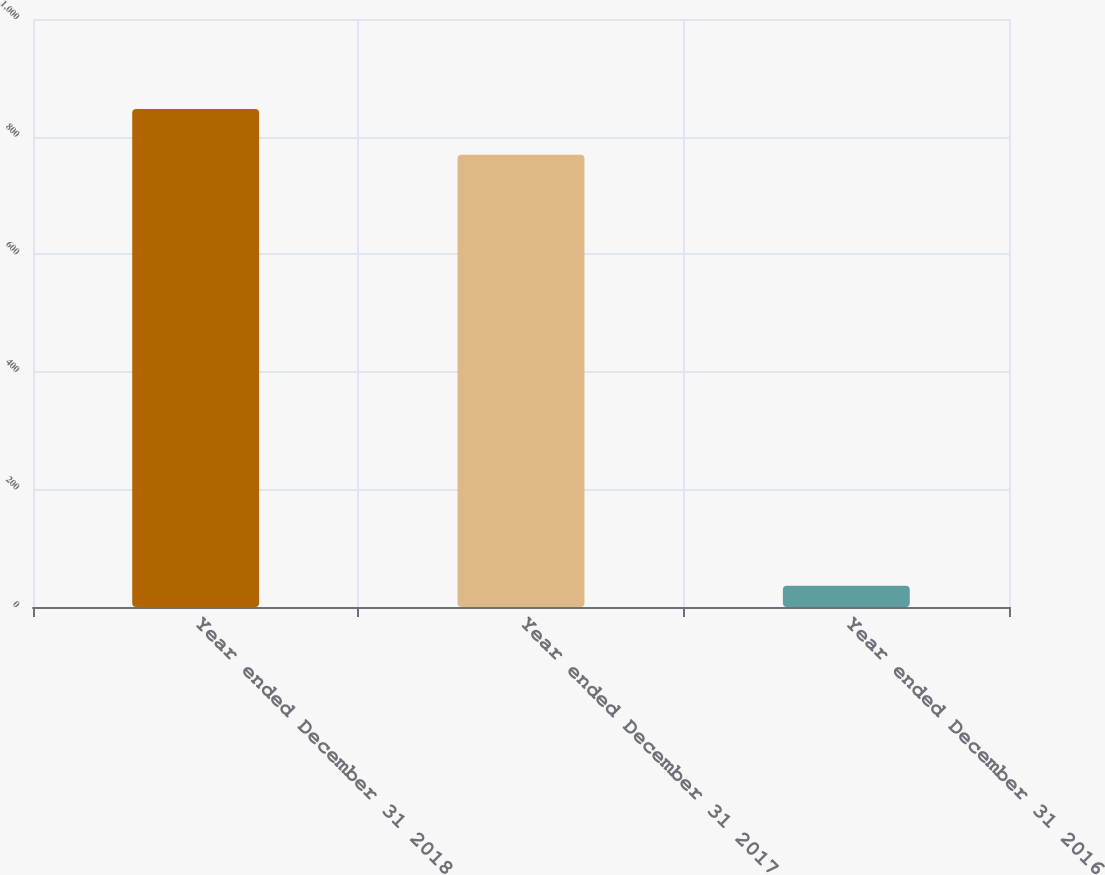Convert chart. <chart><loc_0><loc_0><loc_500><loc_500><bar_chart><fcel>Year ended December 31 2018<fcel>Year ended December 31 2017<fcel>Year ended December 31 2016<nl><fcel>846.8<fcel>769<fcel>36<nl></chart> 